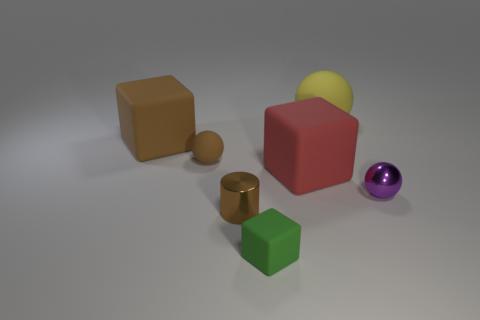Subtract all large red cubes. How many cubes are left? 2 Add 2 tiny cubes. How many objects exist? 9 Subtract all yellow balls. How many balls are left? 2 Add 2 large matte blocks. How many large matte blocks exist? 4 Subtract 0 cyan blocks. How many objects are left? 7 Subtract all cylinders. How many objects are left? 6 Subtract 1 blocks. How many blocks are left? 2 Subtract all gray cylinders. Subtract all green spheres. How many cylinders are left? 1 Subtract all blue balls. How many blue cylinders are left? 0 Subtract all purple cubes. Subtract all yellow things. How many objects are left? 6 